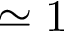<formula> <loc_0><loc_0><loc_500><loc_500>\simeq 1</formula> 